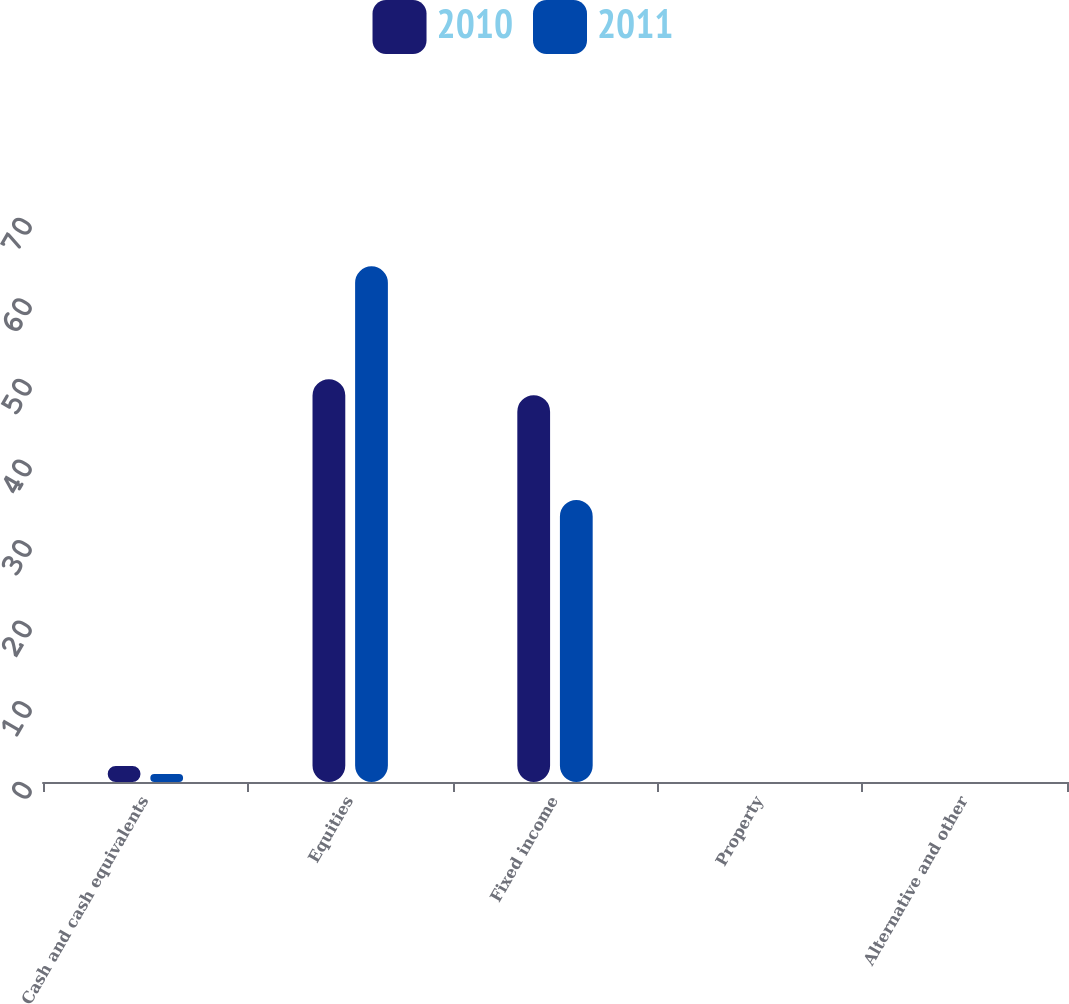<chart> <loc_0><loc_0><loc_500><loc_500><stacked_bar_chart><ecel><fcel>Cash and cash equivalents<fcel>Equities<fcel>Fixed income<fcel>Property<fcel>Alternative and other<nl><fcel>2010<fcel>2<fcel>50<fcel>48<fcel>0<fcel>0<nl><fcel>2011<fcel>1<fcel>64<fcel>35<fcel>0<fcel>0<nl></chart> 